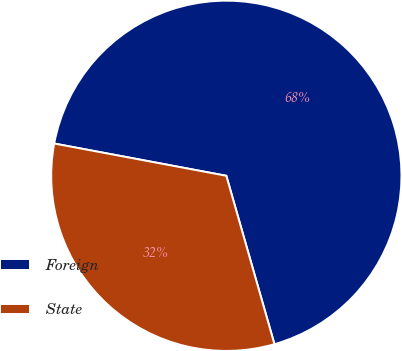Convert chart. <chart><loc_0><loc_0><loc_500><loc_500><pie_chart><fcel>Foreign<fcel>State<nl><fcel>67.62%<fcel>32.38%<nl></chart> 